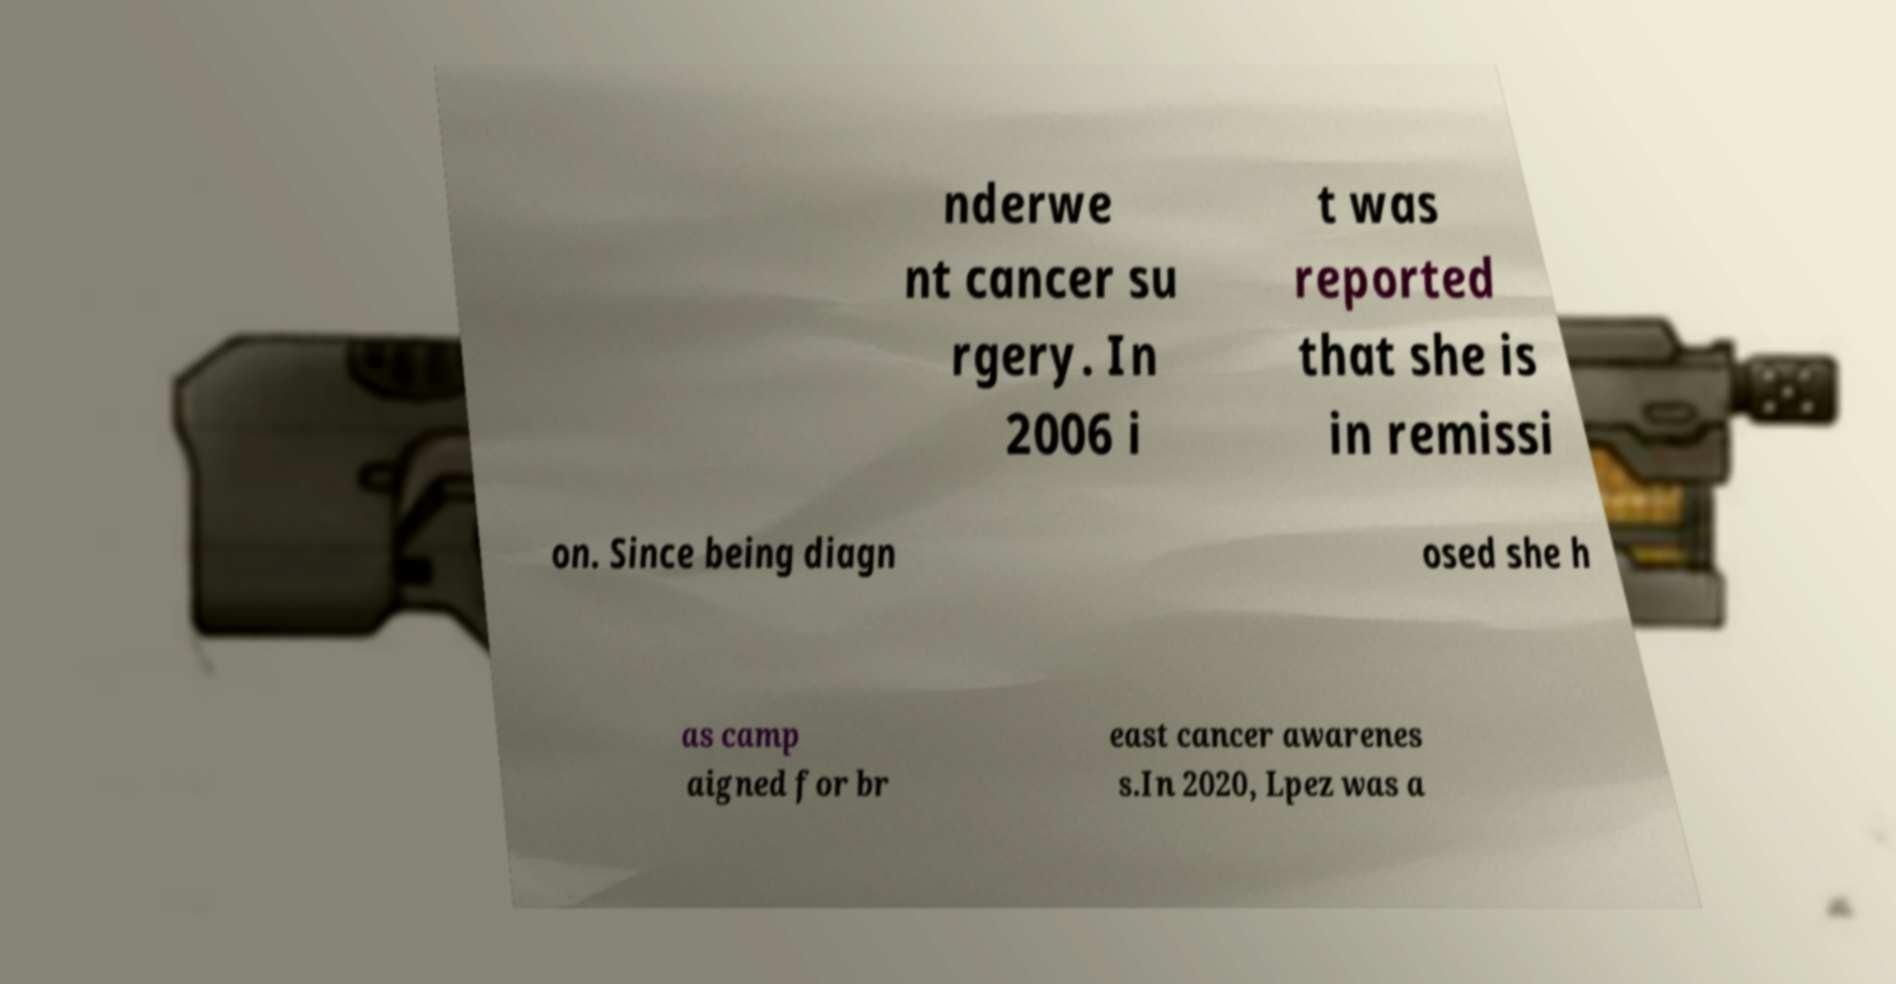For documentation purposes, I need the text within this image transcribed. Could you provide that? nderwe nt cancer su rgery. In 2006 i t was reported that she is in remissi on. Since being diagn osed she h as camp aigned for br east cancer awarenes s.In 2020, Lpez was a 